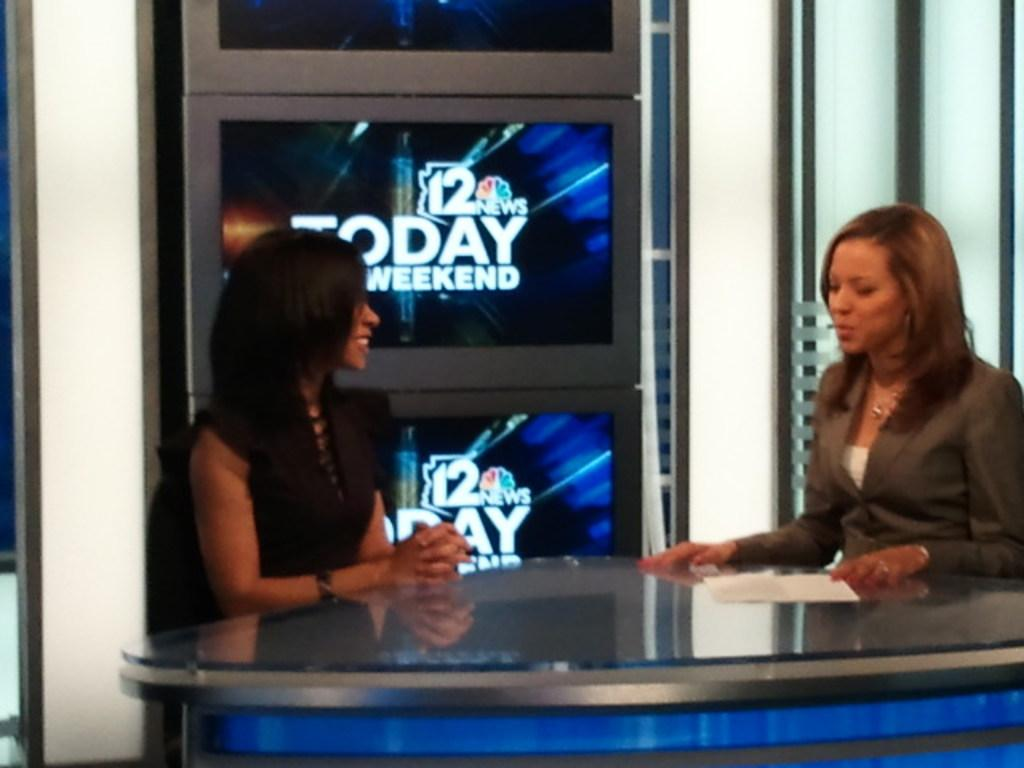<image>
Relay a brief, clear account of the picture shown. Two female news anchors man the desk in front of a 12 Today Weekend graphic. 